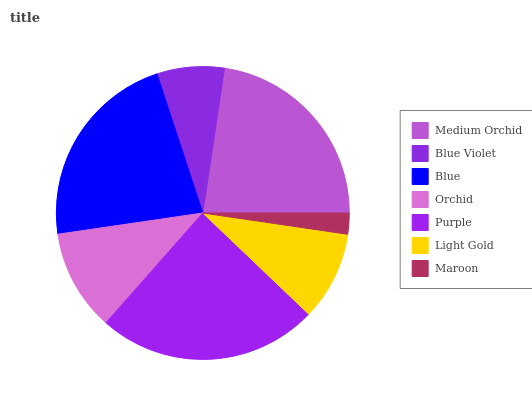Is Maroon the minimum?
Answer yes or no. Yes. Is Purple the maximum?
Answer yes or no. Yes. Is Blue Violet the minimum?
Answer yes or no. No. Is Blue Violet the maximum?
Answer yes or no. No. Is Medium Orchid greater than Blue Violet?
Answer yes or no. Yes. Is Blue Violet less than Medium Orchid?
Answer yes or no. Yes. Is Blue Violet greater than Medium Orchid?
Answer yes or no. No. Is Medium Orchid less than Blue Violet?
Answer yes or no. No. Is Orchid the high median?
Answer yes or no. Yes. Is Orchid the low median?
Answer yes or no. Yes. Is Light Gold the high median?
Answer yes or no. No. Is Purple the low median?
Answer yes or no. No. 